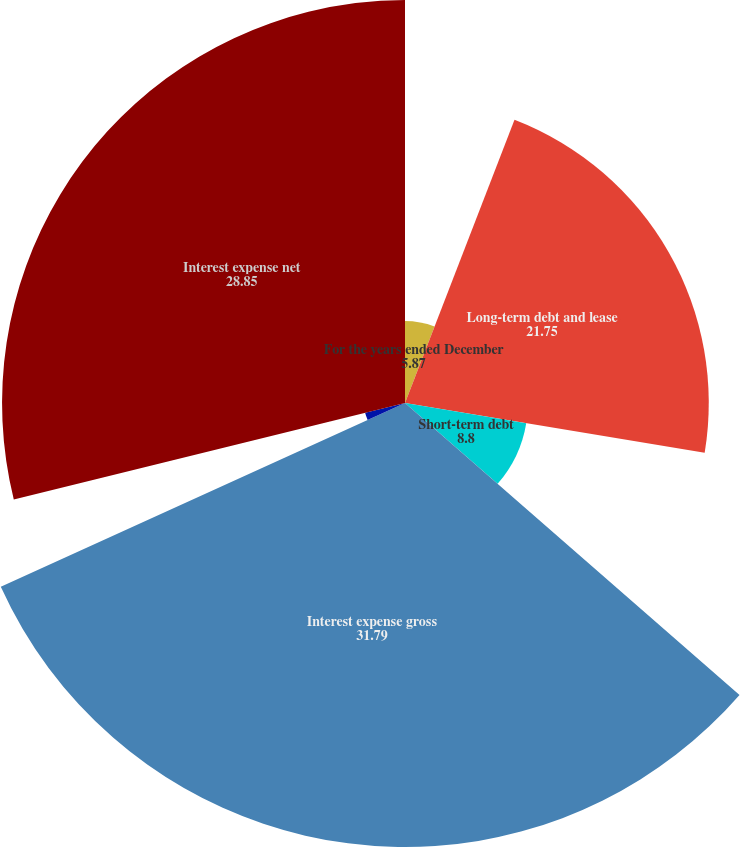<chart> <loc_0><loc_0><loc_500><loc_500><pie_chart><fcel>For the years ended December<fcel>Long-term debt and lease<fcel>Short-term debt<fcel>Capitalized interest<fcel>Interest expense gross<fcel>Interest income<fcel>Interest expense net<nl><fcel>5.87%<fcel>21.75%<fcel>8.8%<fcel>0.0%<fcel>31.79%<fcel>2.94%<fcel>28.85%<nl></chart> 